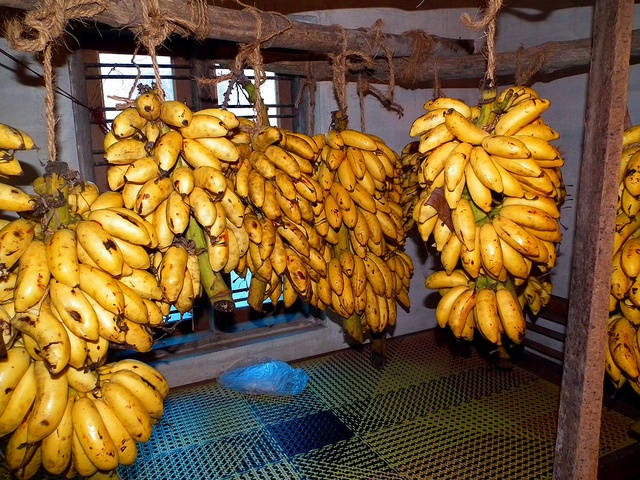Describe the objects in this image and their specific colors. I can see bed in brown, black, darkgreen, and gray tones, banana in brown, orange, olive, gold, and maroon tones, banana in brown, orange, gold, olive, and maroon tones, banana in brown, orange, gold, olive, and maroon tones, and banana in brown, olive, orange, maroon, and black tones in this image. 